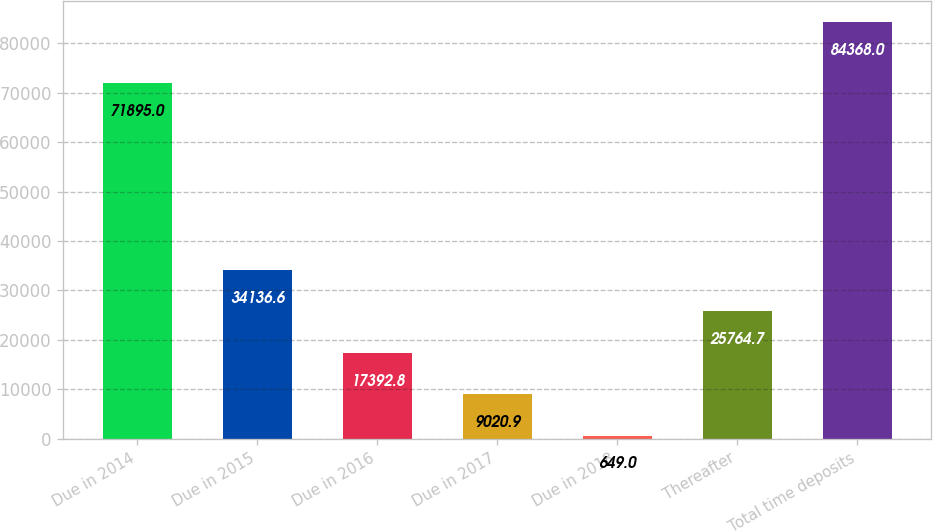<chart> <loc_0><loc_0><loc_500><loc_500><bar_chart><fcel>Due in 2014<fcel>Due in 2015<fcel>Due in 2016<fcel>Due in 2017<fcel>Due in 2018<fcel>Thereafter<fcel>Total time deposits<nl><fcel>71895<fcel>34136.6<fcel>17392.8<fcel>9020.9<fcel>649<fcel>25764.7<fcel>84368<nl></chart> 